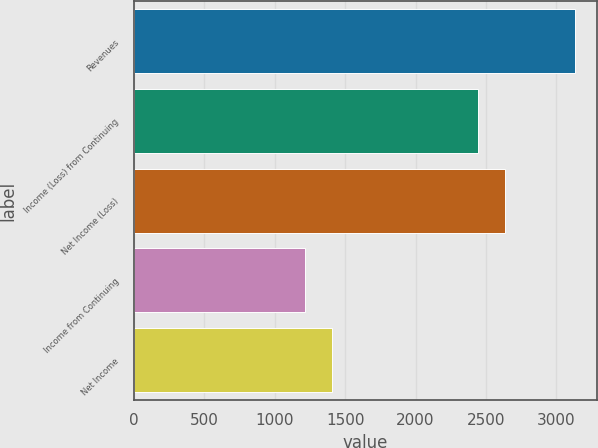Convert chart. <chart><loc_0><loc_0><loc_500><loc_500><bar_chart><fcel>Revenues<fcel>Income (Loss) from Continuing<fcel>Net Income (Loss)<fcel>Income from Continuing<fcel>Net Income<nl><fcel>3133<fcel>2441<fcel>2632.9<fcel>1214<fcel>1405.9<nl></chart> 